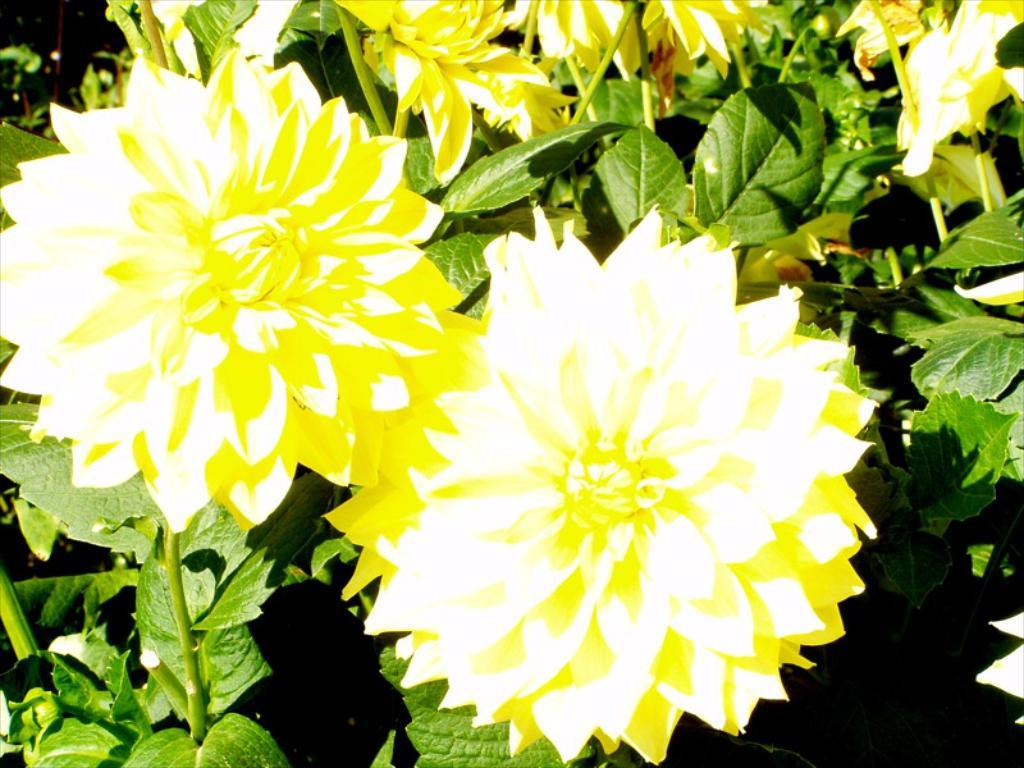How many flowers are present in the image? There are two flowers in the image. What color are the flowers? The flowers are yellow. Are there any other parts of the flowers visible? Yes, there are leaves associated with these flowers. How many baby gooses can be seen eating the yellow flowers in the image? There are no baby gooses visible in the image. The image only features two yellow flowers with leaves associated with them. 